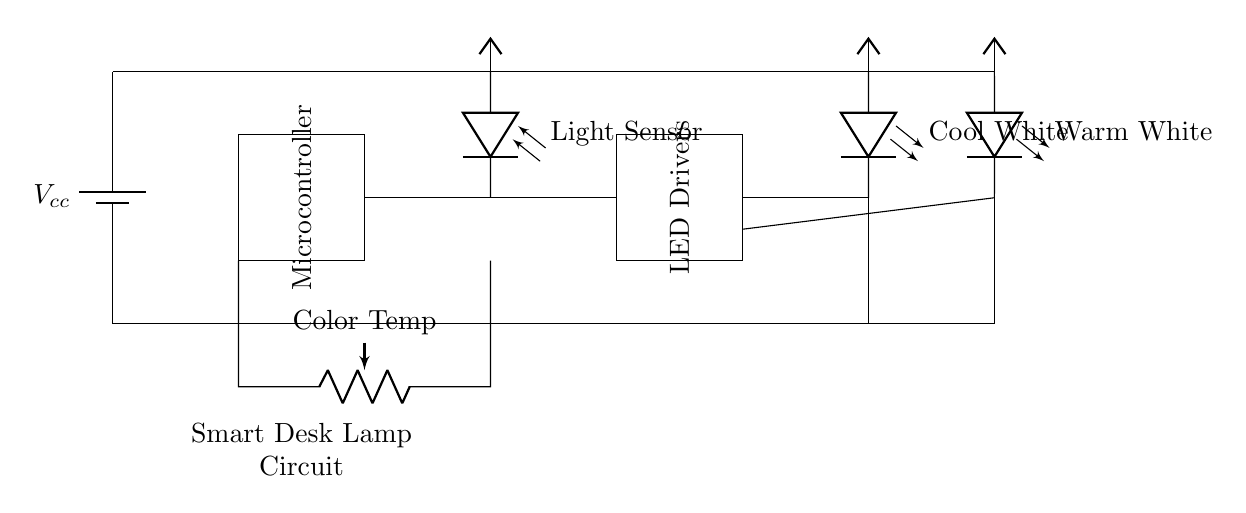What component regulates color temperature? The potentiometer is the component that regulates the color temperature in the circuit by allowing the user to adjust the resistance, influencing the output of the cool and warm white LEDs.
Answer: Potentiometer What are the types of LEDs used in the circuit? The circuit includes two types of LEDs: Cool White and Warm White, which provide different color temperatures for optimal reading conditions.
Answer: Cool White, Warm White How many main components are present in the circuit? The main components include a battery, a microcontroller, a light sensor, a potentiometer for color temperature, LED drivers, and two types of LEDs, totaling six components in the circuit.
Answer: Six What is the power supply voltage for this circuit? There is a battery represented as Vcc supplying a voltage to the circuit, typically indicating a standard value like five volts commonly found in such circuits.
Answer: Vcc Which component connects the light sensor and microcontroller? A wire connection runs from the light sensor to the microcontroller, facilitating communication of light level data to the microcontroller for processing.
Answer: Wire connection What role does the microcontroller play in this circuit? The microcontroller is responsible for processing input from the light sensor and controlling the output to the LED drivers based on user adjustments to the color temperature.
Answer: Processing input 